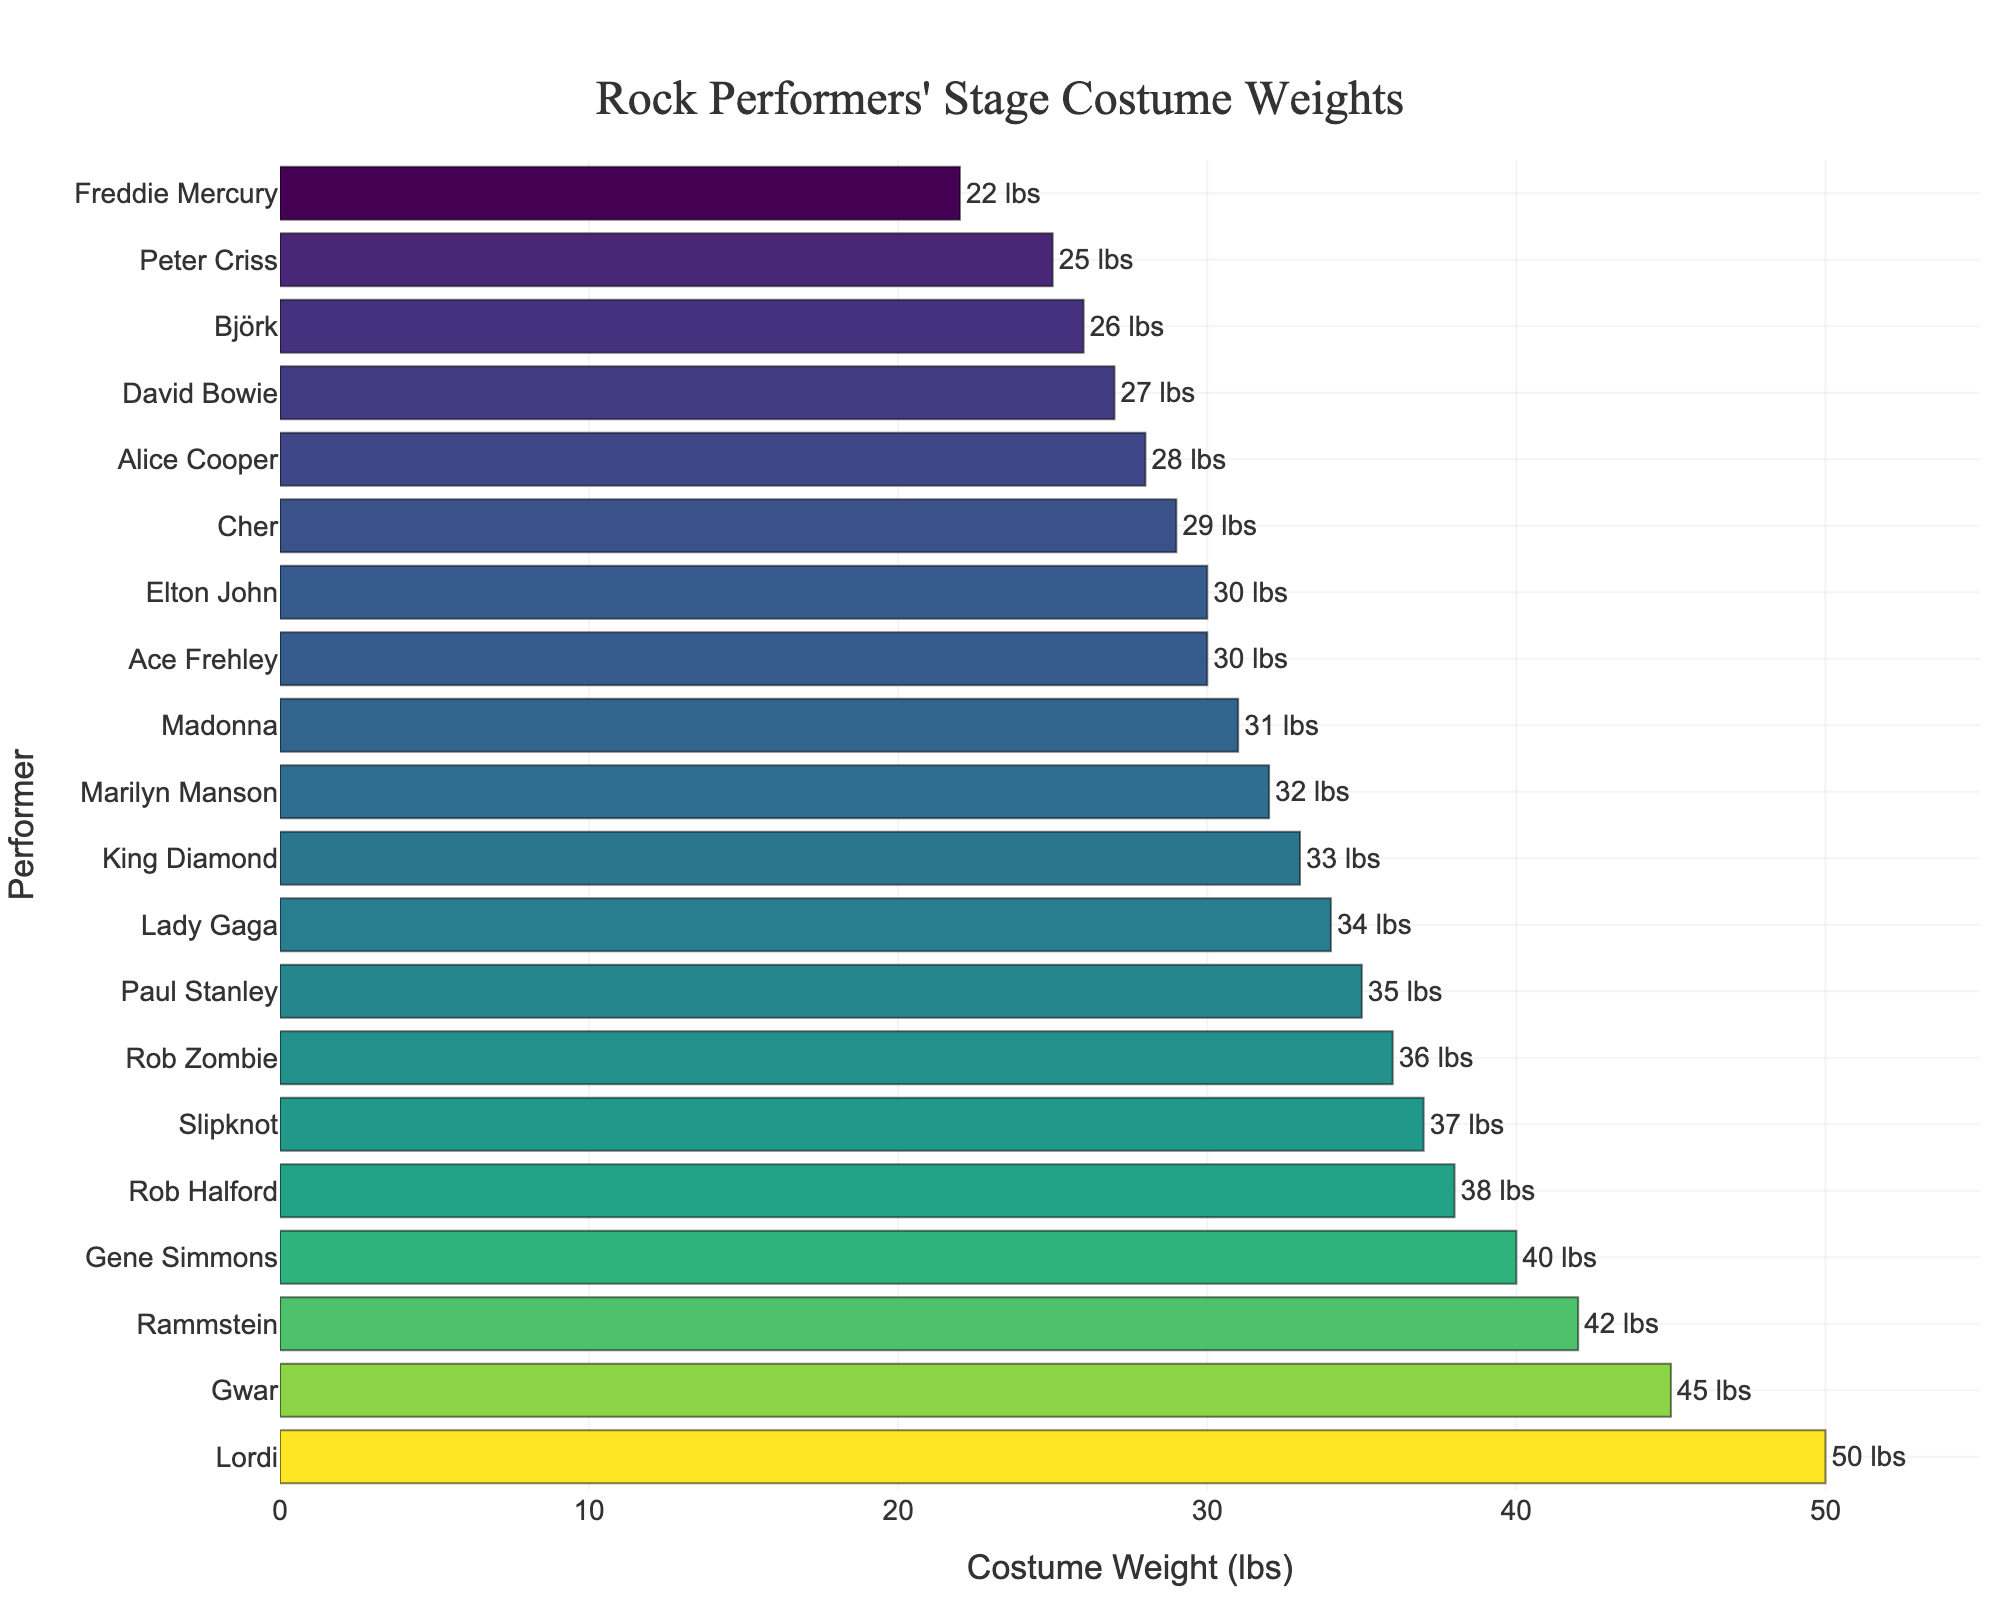How many performers' costume weights are shown in the plot? To find the number of performers, count the distinct bars in the horizontal bar plot.
Answer: 20 Which performer has the heaviest stage costume? Identify the performer associated with the longest bar. Lordi has the heaviest stage costume.
Answer: Lordi What is the total weight of the stage costumes for Gene Simmons, Paul Stanley, and Ace Frehley combined? Sum the weights of the three performers (Gene Simmons: 40 lbs, Paul Stanley: 35 lbs, Ace Frehley: 30 lbs). The total is 40 + 35 + 30.
Answer: 105 lbs Which performer has the lightest stage costume? Identify the performer associated with the shortest bar. Freddie Mercury has the lightest stage costume.
Answer: Freddie Mercury What is the average weight of the stage costumes shown in the plot? Sum all the costume weights and divide by the number of performers. (40 + 35 + 30 + 25 + 28 + 32 + 38 + 33 + 45 + 37 + 42 + 50 + 36 + 30 + 34 + 27 + 22 + 29 + 26 + 31) / 20 = 700 / 20 = 35.
Answer: 35 lbs Is Alice Cooper's costume heavier or lighter than Madonna's? Compare the bar length for Alice Cooper and Madonna. Alice Cooper's costume is listed as 28 lbs, and Madonna's as 31 lbs. Therefore, Alice Cooper's costume is lighter.
Answer: Lighter How many performers have costume weights above 40 lbs? Count the bars with costume weights exceeding 40 lbs. Performers are Gwar, Rammstein, and Lordi.
Answer: 3 What is the difference in costume weight between Marilyn Manson and Cher? Subtract Cher's costume weight from Marilyn Manson's. Marilyn Manson has 32 lbs and Cher has 29 lbs. 32 - 29 = 3.
Answer: 3 lbs Who has a heavier costume, Rob Halford or Slipknot? Compare the bar lengths for Rob Halford and Slipknot. Rob Halford's weight is 38 lbs, and Slipknot's is 37 lbs. Rob Halford has a heavier costume.
Answer: Rob Halford What's the range of the costume weights shown in the plot? Subtract the minimum costume weight from the maximum costume weight. Lordi has the heaviest at 50 lbs, and Freddie Mercury has the lightest at 22 lbs. 50 - 22 = 28.
Answer: 28 lbs 